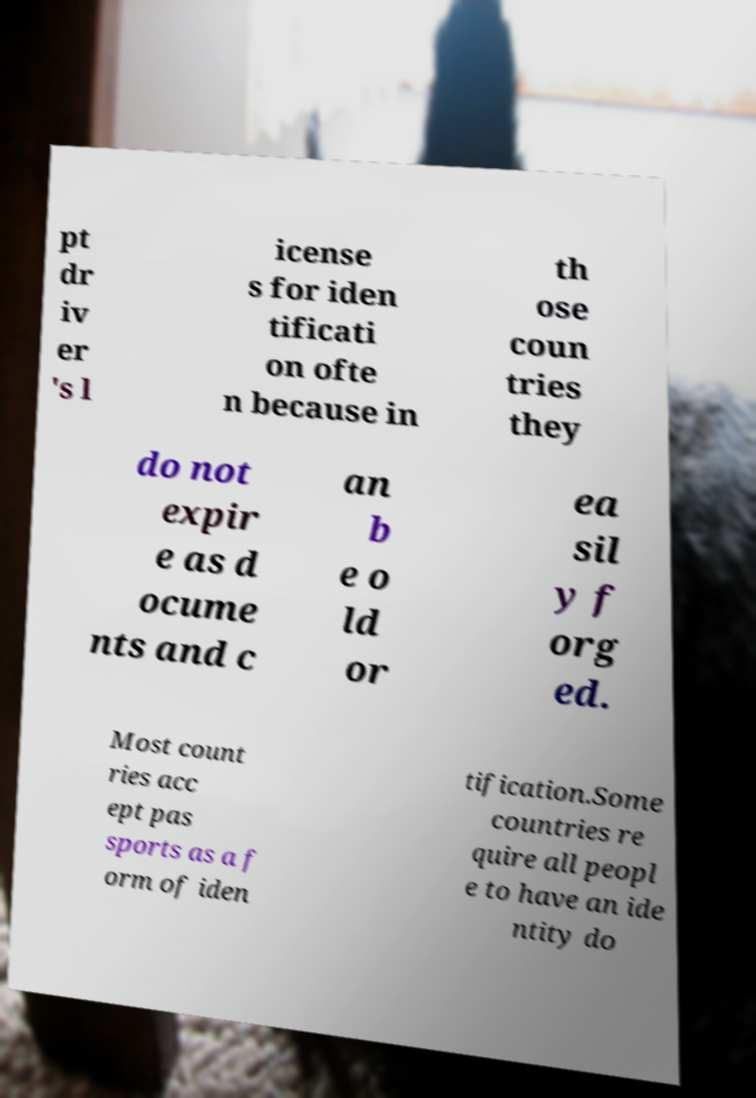What messages or text are displayed in this image? I need them in a readable, typed format. pt dr iv er 's l icense s for iden tificati on ofte n because in th ose coun tries they do not expir e as d ocume nts and c an b e o ld or ea sil y f org ed. Most count ries acc ept pas sports as a f orm of iden tification.Some countries re quire all peopl e to have an ide ntity do 